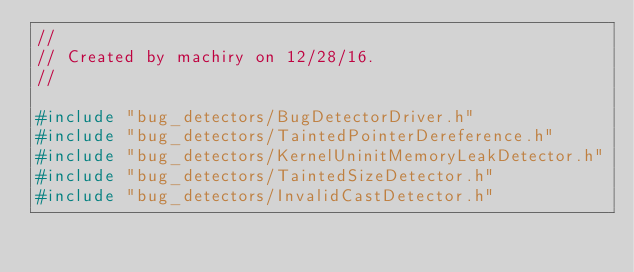<code> <loc_0><loc_0><loc_500><loc_500><_C++_>//
// Created by machiry on 12/28/16.
//

#include "bug_detectors/BugDetectorDriver.h"
#include "bug_detectors/TaintedPointerDereference.h"
#include "bug_detectors/KernelUninitMemoryLeakDetector.h"
#include "bug_detectors/TaintedSizeDetector.h"
#include "bug_detectors/InvalidCastDetector.h"</code> 